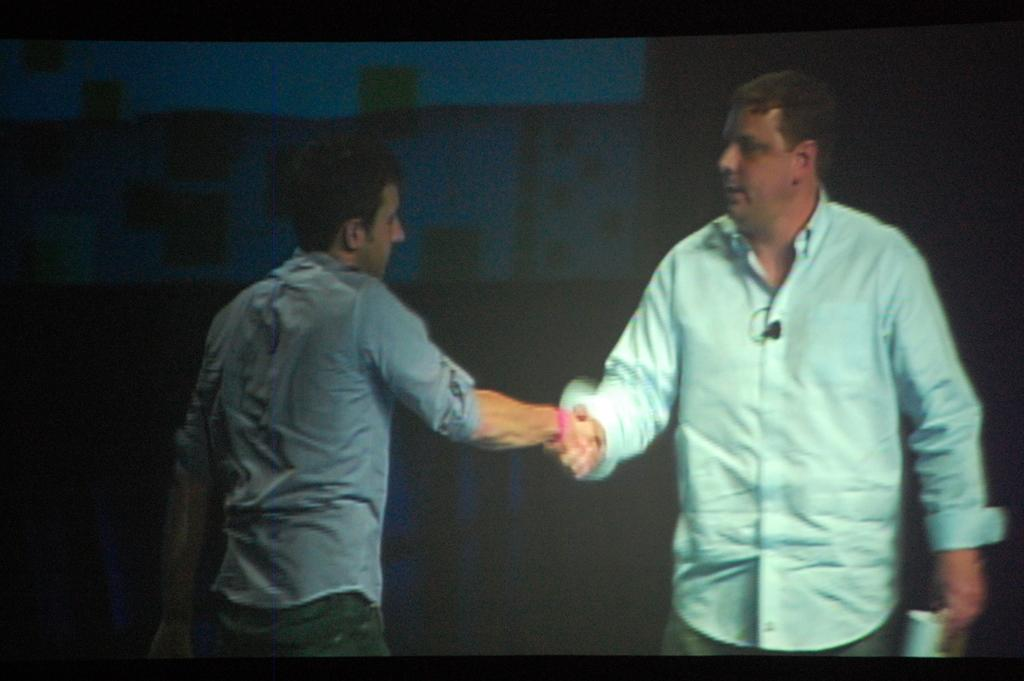How many people are in the image? There are two men in the image. What are the two men doing in the image? The two men are shaking hands. What can be observed about the background of the image? The background of the image is dark. What type of range can be seen in the image? There is no range present in the image; it features two men shaking hands with a dark background. 